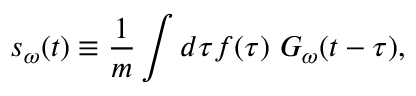Convert formula to latex. <formula><loc_0><loc_0><loc_500><loc_500>s _ { \omega } ( t ) \equiv \frac { 1 } { m } \int d \tau f ( \tau ) \ G _ { \omega } ( t - \tau ) ,</formula> 